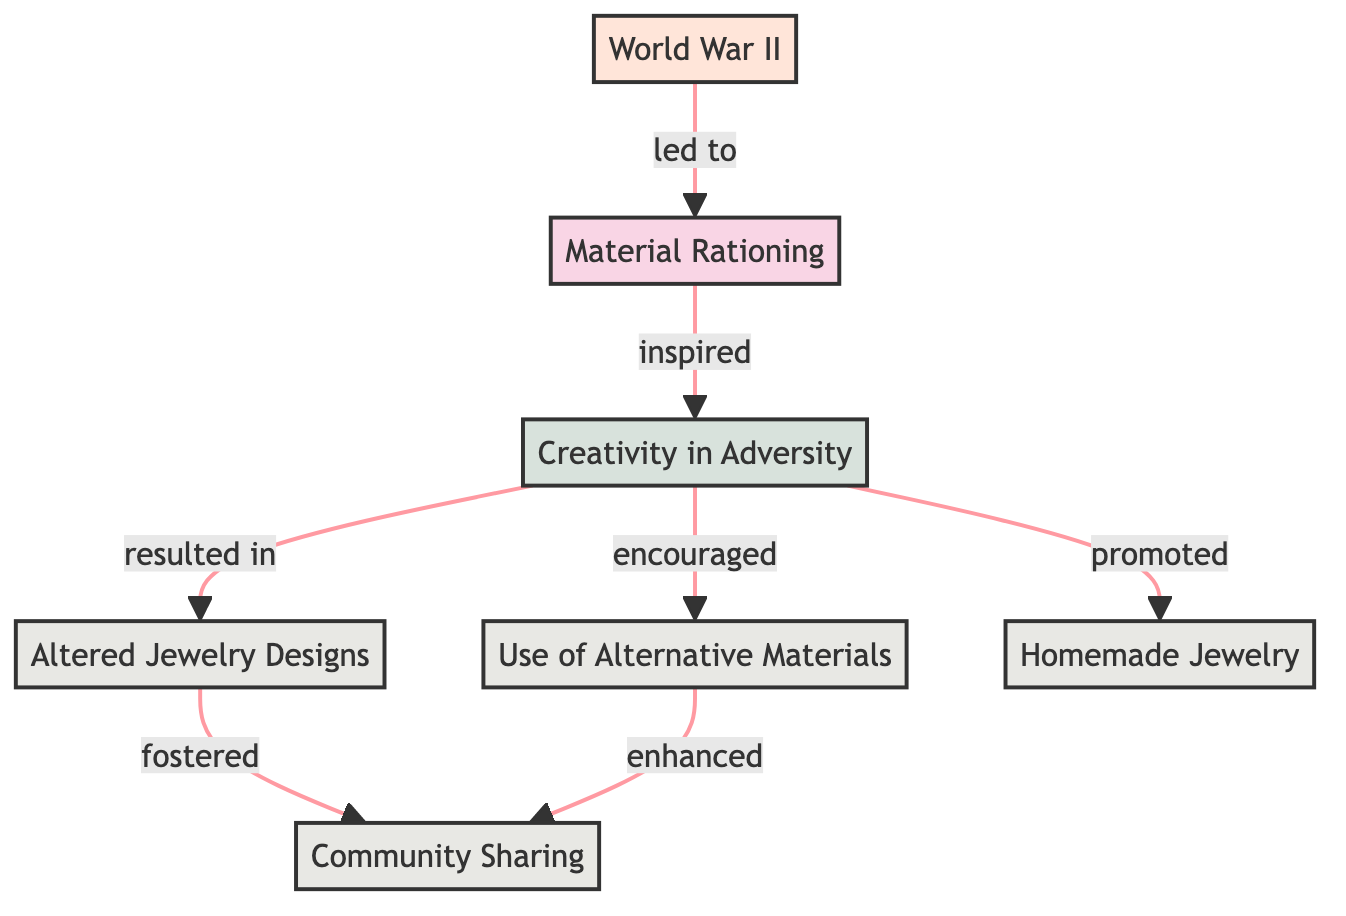What is the starting point of the diagram? The starting point of the diagram is "World War II," as it is the root node from which all other connections stem.
Answer: World War II How many nodes are present in the diagram? The diagram includes a total of 7 nodes representing various concepts related to the theme.
Answer: 7 Which node directly results from "Material Rationing"? "Creativity in Adversity" is the node that directly results from "Material Rationing," as it connects directly to it in the diagram.
Answer: Creativity in Adversity What is the relationship between "Creativity in Adversity" and "Altered Jewelry Designs"? "Creativity in Adversity" leads to "Altered Jewelry Designs," indicating that the former inspires the latter.
Answer: resulted in How many edges connect the node "Creativity in Adversity" to other nodes? The node "Creativity in Adversity" connects to three other nodes via edges, showing the various outcomes of the creativity sparked during wartime.
Answer: 3 Which node promotes "Community Sharing"? "Altered Jewelry Designs" and "Use of Alternative Materials" both promote "Community Sharing," as they connect to it in the diagram.
Answer: Altered Jewelry Designs, Use of Alternative Materials What does "Material Rationing" inspire according to the diagram? "Material Rationing" inspires "Creativity in Adversity," showing how limitations can lead to innovative solutions.
Answer: Creativity in Adversity What is the outcome of "Homemade Jewelry"? "Homemade Jewelry" fosters "Community Sharing," highlighting the collaborative spirit and communal bonds created through shared jewelry-making efforts.
Answer: Community Sharing How does "Use of Alternative Materials" enhance the concept of "Community Sharing"? "Use of Alternative Materials" enhances "Community Sharing" by illustrating how different resources were creatively utilized to connect and share among community members.
Answer: enhances 